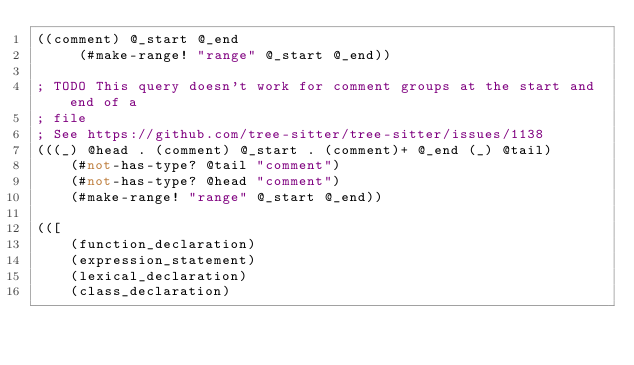<code> <loc_0><loc_0><loc_500><loc_500><_Scheme_>((comment) @_start @_end
     (#make-range! "range" @_start @_end))

; TODO This query doesn't work for comment groups at the start and end of a
; file
; See https://github.com/tree-sitter/tree-sitter/issues/1138
(((_) @head . (comment) @_start . (comment)+ @_end (_) @tail)
    (#not-has-type? @tail "comment")
    (#not-has-type? @head "comment")
    (#make-range! "range" @_start @_end))

(([
    (function_declaration)
    (expression_statement)
    (lexical_declaration)
    (class_declaration)</code> 